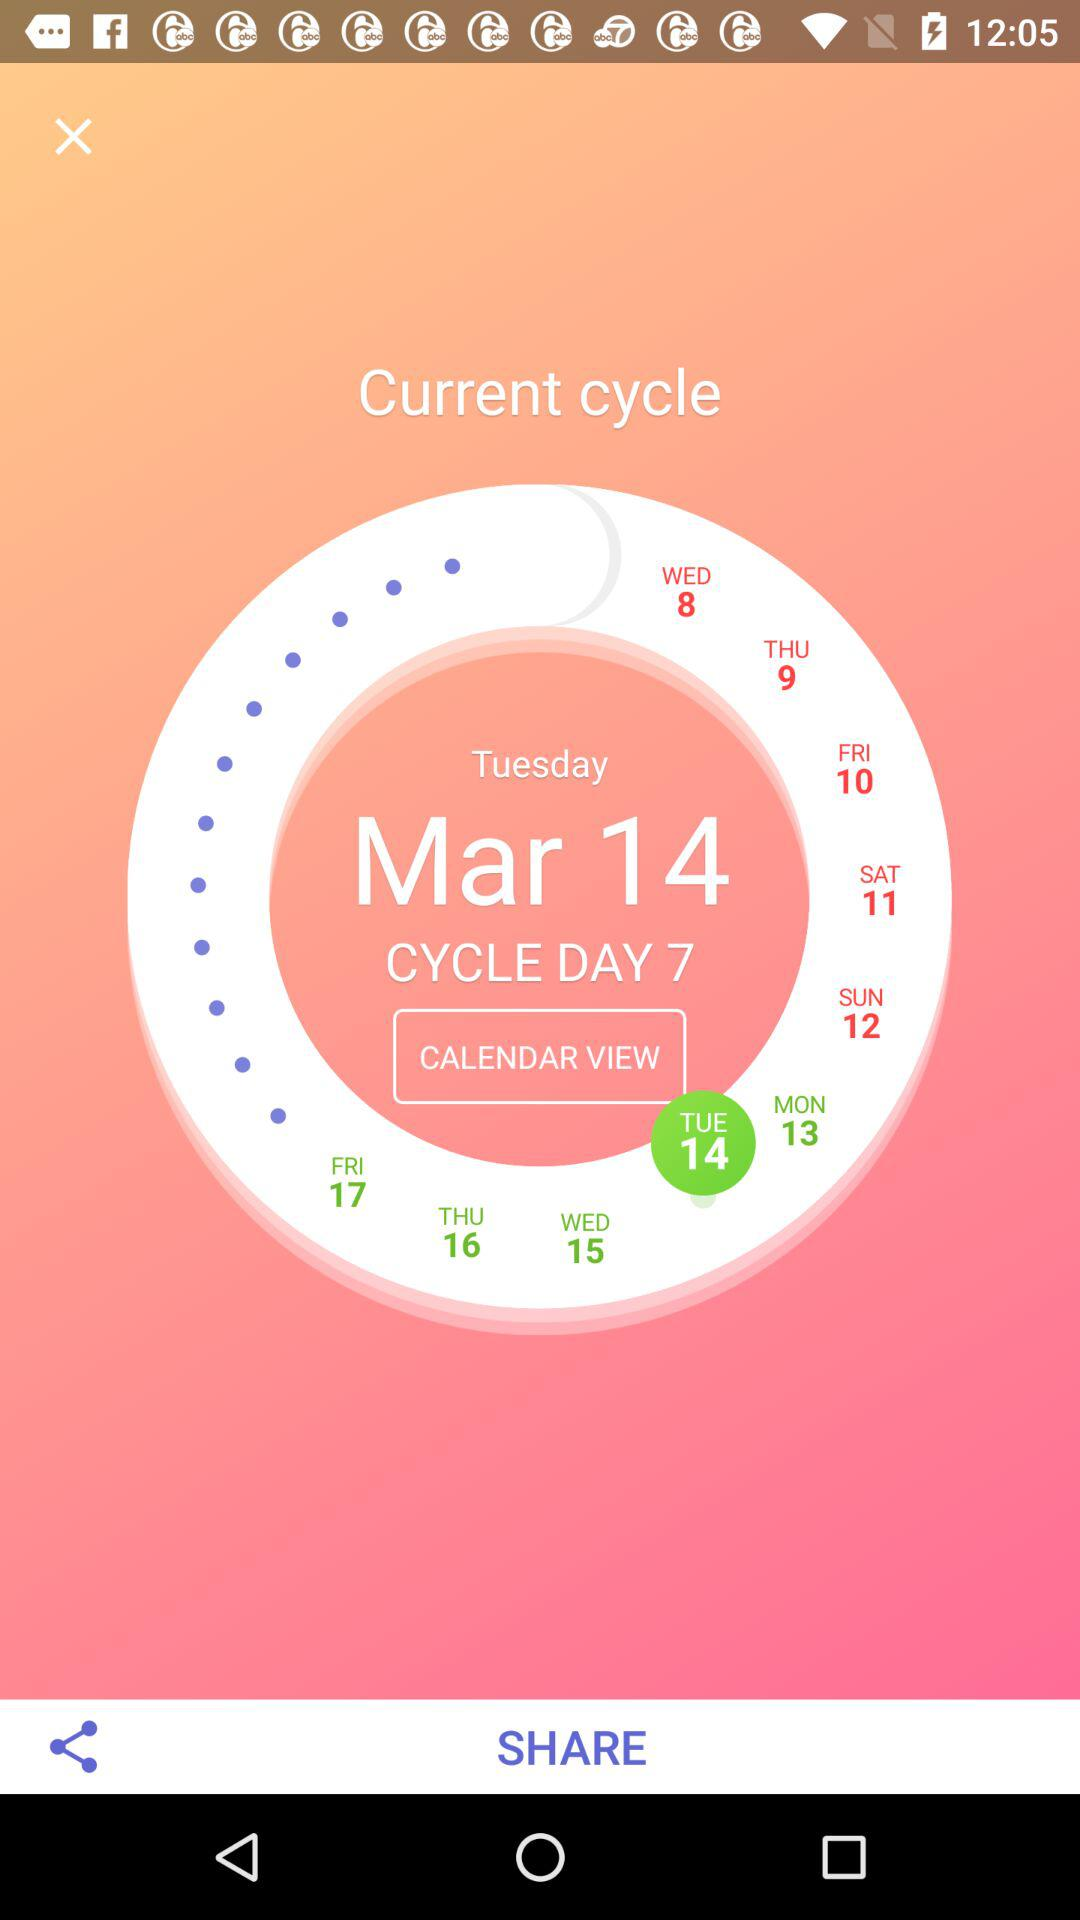What's the "Current cycle" date? The date is Tuesday, March 14. 